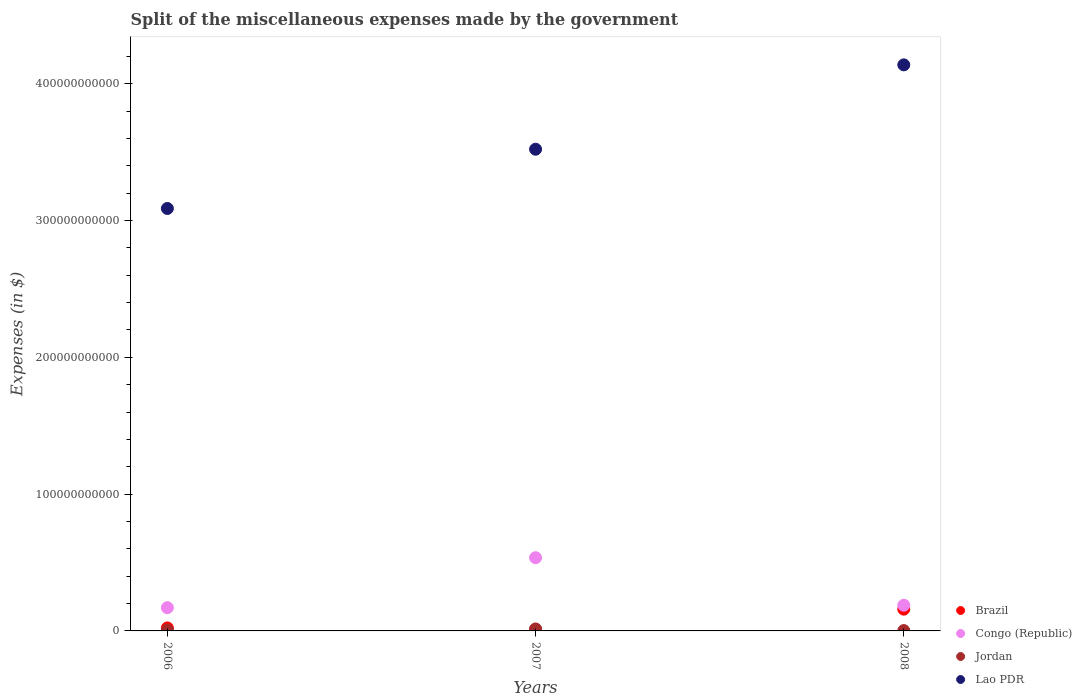What is the miscellaneous expenses made by the government in Brazil in 2006?
Offer a terse response. 2.18e+09. Across all years, what is the maximum miscellaneous expenses made by the government in Congo (Republic)?
Provide a short and direct response. 5.35e+1. Across all years, what is the minimum miscellaneous expenses made by the government in Jordan?
Offer a very short reply. 2.55e+08. What is the total miscellaneous expenses made by the government in Jordan in the graph?
Keep it short and to the point. 2.24e+09. What is the difference between the miscellaneous expenses made by the government in Lao PDR in 2006 and that in 2007?
Offer a terse response. -4.33e+1. What is the difference between the miscellaneous expenses made by the government in Brazil in 2007 and the miscellaneous expenses made by the government in Congo (Republic) in 2008?
Ensure brevity in your answer.  -1.77e+1. What is the average miscellaneous expenses made by the government in Congo (Republic) per year?
Your response must be concise. 2.98e+1. In the year 2007, what is the difference between the miscellaneous expenses made by the government in Brazil and miscellaneous expenses made by the government in Jordan?
Give a very brief answer. -4.19e+08. What is the ratio of the miscellaneous expenses made by the government in Brazil in 2006 to that in 2008?
Provide a succinct answer. 0.14. Is the difference between the miscellaneous expenses made by the government in Brazil in 2006 and 2008 greater than the difference between the miscellaneous expenses made by the government in Jordan in 2006 and 2008?
Give a very brief answer. No. What is the difference between the highest and the second highest miscellaneous expenses made by the government in Jordan?
Make the answer very short. 8.96e+08. What is the difference between the highest and the lowest miscellaneous expenses made by the government in Lao PDR?
Provide a short and direct response. 1.05e+11. In how many years, is the miscellaneous expenses made by the government in Brazil greater than the average miscellaneous expenses made by the government in Brazil taken over all years?
Offer a terse response. 1. Is the sum of the miscellaneous expenses made by the government in Congo (Republic) in 2007 and 2008 greater than the maximum miscellaneous expenses made by the government in Brazil across all years?
Provide a succinct answer. Yes. Is it the case that in every year, the sum of the miscellaneous expenses made by the government in Jordan and miscellaneous expenses made by the government in Brazil  is greater than the miscellaneous expenses made by the government in Congo (Republic)?
Give a very brief answer. No. How many years are there in the graph?
Keep it short and to the point. 3. What is the difference between two consecutive major ticks on the Y-axis?
Keep it short and to the point. 1.00e+11. Are the values on the major ticks of Y-axis written in scientific E-notation?
Ensure brevity in your answer.  No. Does the graph contain any zero values?
Keep it short and to the point. No. Does the graph contain grids?
Make the answer very short. No. How many legend labels are there?
Offer a terse response. 4. How are the legend labels stacked?
Offer a terse response. Vertical. What is the title of the graph?
Provide a short and direct response. Split of the miscellaneous expenses made by the government. What is the label or title of the Y-axis?
Give a very brief answer. Expenses (in $). What is the Expenses (in $) of Brazil in 2006?
Provide a short and direct response. 2.18e+09. What is the Expenses (in $) of Congo (Republic) in 2006?
Provide a short and direct response. 1.70e+1. What is the Expenses (in $) of Jordan in 2006?
Your answer should be very brief. 5.42e+08. What is the Expenses (in $) in Lao PDR in 2006?
Keep it short and to the point. 3.09e+11. What is the Expenses (in $) in Brazil in 2007?
Give a very brief answer. 1.02e+09. What is the Expenses (in $) of Congo (Republic) in 2007?
Your answer should be very brief. 5.35e+1. What is the Expenses (in $) in Jordan in 2007?
Your answer should be compact. 1.44e+09. What is the Expenses (in $) in Lao PDR in 2007?
Ensure brevity in your answer.  3.52e+11. What is the Expenses (in $) in Brazil in 2008?
Keep it short and to the point. 1.59e+1. What is the Expenses (in $) in Congo (Republic) in 2008?
Offer a very short reply. 1.88e+1. What is the Expenses (in $) of Jordan in 2008?
Keep it short and to the point. 2.55e+08. What is the Expenses (in $) in Lao PDR in 2008?
Provide a short and direct response. 4.14e+11. Across all years, what is the maximum Expenses (in $) of Brazil?
Offer a terse response. 1.59e+1. Across all years, what is the maximum Expenses (in $) in Congo (Republic)?
Make the answer very short. 5.35e+1. Across all years, what is the maximum Expenses (in $) of Jordan?
Your answer should be very brief. 1.44e+09. Across all years, what is the maximum Expenses (in $) in Lao PDR?
Ensure brevity in your answer.  4.14e+11. Across all years, what is the minimum Expenses (in $) in Brazil?
Make the answer very short. 1.02e+09. Across all years, what is the minimum Expenses (in $) in Congo (Republic)?
Make the answer very short. 1.70e+1. Across all years, what is the minimum Expenses (in $) of Jordan?
Keep it short and to the point. 2.55e+08. Across all years, what is the minimum Expenses (in $) in Lao PDR?
Give a very brief answer. 3.09e+11. What is the total Expenses (in $) in Brazil in the graph?
Provide a succinct answer. 1.91e+1. What is the total Expenses (in $) of Congo (Republic) in the graph?
Offer a terse response. 8.93e+1. What is the total Expenses (in $) of Jordan in the graph?
Provide a short and direct response. 2.24e+09. What is the total Expenses (in $) in Lao PDR in the graph?
Give a very brief answer. 1.07e+12. What is the difference between the Expenses (in $) of Brazil in 2006 and that in 2007?
Make the answer very short. 1.16e+09. What is the difference between the Expenses (in $) of Congo (Republic) in 2006 and that in 2007?
Ensure brevity in your answer.  -3.65e+1. What is the difference between the Expenses (in $) of Jordan in 2006 and that in 2007?
Provide a short and direct response. -8.96e+08. What is the difference between the Expenses (in $) in Lao PDR in 2006 and that in 2007?
Give a very brief answer. -4.33e+1. What is the difference between the Expenses (in $) of Brazil in 2006 and that in 2008?
Your answer should be very brief. -1.37e+1. What is the difference between the Expenses (in $) of Congo (Republic) in 2006 and that in 2008?
Offer a terse response. -1.77e+09. What is the difference between the Expenses (in $) of Jordan in 2006 and that in 2008?
Your response must be concise. 2.87e+08. What is the difference between the Expenses (in $) of Lao PDR in 2006 and that in 2008?
Keep it short and to the point. -1.05e+11. What is the difference between the Expenses (in $) in Brazil in 2007 and that in 2008?
Ensure brevity in your answer.  -1.49e+1. What is the difference between the Expenses (in $) of Congo (Republic) in 2007 and that in 2008?
Your answer should be very brief. 3.48e+1. What is the difference between the Expenses (in $) of Jordan in 2007 and that in 2008?
Give a very brief answer. 1.18e+09. What is the difference between the Expenses (in $) of Lao PDR in 2007 and that in 2008?
Keep it short and to the point. -6.17e+1. What is the difference between the Expenses (in $) in Brazil in 2006 and the Expenses (in $) in Congo (Republic) in 2007?
Provide a short and direct response. -5.14e+1. What is the difference between the Expenses (in $) of Brazil in 2006 and the Expenses (in $) of Jordan in 2007?
Make the answer very short. 7.39e+08. What is the difference between the Expenses (in $) in Brazil in 2006 and the Expenses (in $) in Lao PDR in 2007?
Your answer should be very brief. -3.50e+11. What is the difference between the Expenses (in $) in Congo (Republic) in 2006 and the Expenses (in $) in Jordan in 2007?
Provide a succinct answer. 1.56e+1. What is the difference between the Expenses (in $) in Congo (Republic) in 2006 and the Expenses (in $) in Lao PDR in 2007?
Provide a short and direct response. -3.35e+11. What is the difference between the Expenses (in $) in Jordan in 2006 and the Expenses (in $) in Lao PDR in 2007?
Your response must be concise. -3.52e+11. What is the difference between the Expenses (in $) in Brazil in 2006 and the Expenses (in $) in Congo (Republic) in 2008?
Your answer should be very brief. -1.66e+1. What is the difference between the Expenses (in $) of Brazil in 2006 and the Expenses (in $) of Jordan in 2008?
Your answer should be very brief. 1.92e+09. What is the difference between the Expenses (in $) of Brazil in 2006 and the Expenses (in $) of Lao PDR in 2008?
Offer a very short reply. -4.12e+11. What is the difference between the Expenses (in $) in Congo (Republic) in 2006 and the Expenses (in $) in Jordan in 2008?
Make the answer very short. 1.67e+1. What is the difference between the Expenses (in $) in Congo (Republic) in 2006 and the Expenses (in $) in Lao PDR in 2008?
Offer a very short reply. -3.97e+11. What is the difference between the Expenses (in $) in Jordan in 2006 and the Expenses (in $) in Lao PDR in 2008?
Give a very brief answer. -4.13e+11. What is the difference between the Expenses (in $) in Brazil in 2007 and the Expenses (in $) in Congo (Republic) in 2008?
Provide a succinct answer. -1.77e+1. What is the difference between the Expenses (in $) of Brazil in 2007 and the Expenses (in $) of Jordan in 2008?
Provide a succinct answer. 7.64e+08. What is the difference between the Expenses (in $) of Brazil in 2007 and the Expenses (in $) of Lao PDR in 2008?
Offer a terse response. -4.13e+11. What is the difference between the Expenses (in $) of Congo (Republic) in 2007 and the Expenses (in $) of Jordan in 2008?
Provide a short and direct response. 5.33e+1. What is the difference between the Expenses (in $) of Congo (Republic) in 2007 and the Expenses (in $) of Lao PDR in 2008?
Give a very brief answer. -3.60e+11. What is the difference between the Expenses (in $) in Jordan in 2007 and the Expenses (in $) in Lao PDR in 2008?
Make the answer very short. -4.12e+11. What is the average Expenses (in $) in Brazil per year?
Give a very brief answer. 6.37e+09. What is the average Expenses (in $) of Congo (Republic) per year?
Keep it short and to the point. 2.98e+1. What is the average Expenses (in $) of Jordan per year?
Make the answer very short. 7.45e+08. What is the average Expenses (in $) in Lao PDR per year?
Your answer should be very brief. 3.58e+11. In the year 2006, what is the difference between the Expenses (in $) of Brazil and Expenses (in $) of Congo (Republic)?
Provide a succinct answer. -1.48e+1. In the year 2006, what is the difference between the Expenses (in $) in Brazil and Expenses (in $) in Jordan?
Your response must be concise. 1.64e+09. In the year 2006, what is the difference between the Expenses (in $) in Brazil and Expenses (in $) in Lao PDR?
Your answer should be compact. -3.07e+11. In the year 2006, what is the difference between the Expenses (in $) of Congo (Republic) and Expenses (in $) of Jordan?
Your response must be concise. 1.65e+1. In the year 2006, what is the difference between the Expenses (in $) of Congo (Republic) and Expenses (in $) of Lao PDR?
Give a very brief answer. -2.92e+11. In the year 2006, what is the difference between the Expenses (in $) of Jordan and Expenses (in $) of Lao PDR?
Ensure brevity in your answer.  -3.08e+11. In the year 2007, what is the difference between the Expenses (in $) in Brazil and Expenses (in $) in Congo (Republic)?
Offer a terse response. -5.25e+1. In the year 2007, what is the difference between the Expenses (in $) of Brazil and Expenses (in $) of Jordan?
Your answer should be very brief. -4.19e+08. In the year 2007, what is the difference between the Expenses (in $) of Brazil and Expenses (in $) of Lao PDR?
Offer a very short reply. -3.51e+11. In the year 2007, what is the difference between the Expenses (in $) in Congo (Republic) and Expenses (in $) in Jordan?
Your answer should be very brief. 5.21e+1. In the year 2007, what is the difference between the Expenses (in $) in Congo (Republic) and Expenses (in $) in Lao PDR?
Your response must be concise. -2.99e+11. In the year 2007, what is the difference between the Expenses (in $) of Jordan and Expenses (in $) of Lao PDR?
Offer a very short reply. -3.51e+11. In the year 2008, what is the difference between the Expenses (in $) in Brazil and Expenses (in $) in Congo (Republic)?
Provide a succinct answer. -2.85e+09. In the year 2008, what is the difference between the Expenses (in $) in Brazil and Expenses (in $) in Jordan?
Make the answer very short. 1.57e+1. In the year 2008, what is the difference between the Expenses (in $) of Brazil and Expenses (in $) of Lao PDR?
Provide a short and direct response. -3.98e+11. In the year 2008, what is the difference between the Expenses (in $) in Congo (Republic) and Expenses (in $) in Jordan?
Ensure brevity in your answer.  1.85e+1. In the year 2008, what is the difference between the Expenses (in $) in Congo (Republic) and Expenses (in $) in Lao PDR?
Offer a very short reply. -3.95e+11. In the year 2008, what is the difference between the Expenses (in $) in Jordan and Expenses (in $) in Lao PDR?
Offer a terse response. -4.14e+11. What is the ratio of the Expenses (in $) in Brazil in 2006 to that in 2007?
Your answer should be very brief. 2.14. What is the ratio of the Expenses (in $) in Congo (Republic) in 2006 to that in 2007?
Ensure brevity in your answer.  0.32. What is the ratio of the Expenses (in $) of Jordan in 2006 to that in 2007?
Your answer should be very brief. 0.38. What is the ratio of the Expenses (in $) in Lao PDR in 2006 to that in 2007?
Offer a terse response. 0.88. What is the ratio of the Expenses (in $) in Brazil in 2006 to that in 2008?
Ensure brevity in your answer.  0.14. What is the ratio of the Expenses (in $) of Congo (Republic) in 2006 to that in 2008?
Your response must be concise. 0.91. What is the ratio of the Expenses (in $) in Jordan in 2006 to that in 2008?
Your answer should be very brief. 2.12. What is the ratio of the Expenses (in $) of Lao PDR in 2006 to that in 2008?
Make the answer very short. 0.75. What is the ratio of the Expenses (in $) in Brazil in 2007 to that in 2008?
Your answer should be very brief. 0.06. What is the ratio of the Expenses (in $) in Congo (Republic) in 2007 to that in 2008?
Offer a very short reply. 2.85. What is the ratio of the Expenses (in $) of Jordan in 2007 to that in 2008?
Give a very brief answer. 5.63. What is the ratio of the Expenses (in $) in Lao PDR in 2007 to that in 2008?
Ensure brevity in your answer.  0.85. What is the difference between the highest and the second highest Expenses (in $) of Brazil?
Your answer should be very brief. 1.37e+1. What is the difference between the highest and the second highest Expenses (in $) of Congo (Republic)?
Provide a succinct answer. 3.48e+1. What is the difference between the highest and the second highest Expenses (in $) of Jordan?
Give a very brief answer. 8.96e+08. What is the difference between the highest and the second highest Expenses (in $) of Lao PDR?
Offer a terse response. 6.17e+1. What is the difference between the highest and the lowest Expenses (in $) in Brazil?
Offer a very short reply. 1.49e+1. What is the difference between the highest and the lowest Expenses (in $) of Congo (Republic)?
Provide a short and direct response. 3.65e+1. What is the difference between the highest and the lowest Expenses (in $) of Jordan?
Give a very brief answer. 1.18e+09. What is the difference between the highest and the lowest Expenses (in $) in Lao PDR?
Keep it short and to the point. 1.05e+11. 